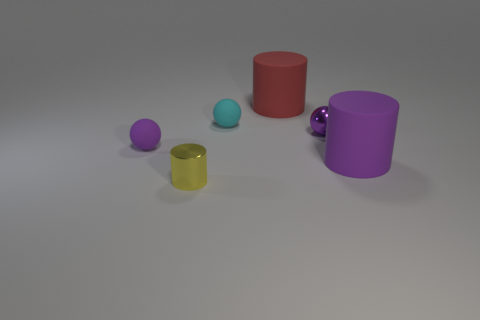What is the size of the rubber cylinder that is the same color as the metallic sphere?
Offer a very short reply. Large. There is another sphere that is the same color as the tiny metal sphere; what material is it?
Your answer should be very brief. Rubber. The tiny cylinder is what color?
Keep it short and to the point. Yellow. How many other objects are the same color as the metal ball?
Offer a terse response. 2. What number of other objects are there of the same material as the tiny cyan ball?
Provide a succinct answer. 3. There is a big matte thing behind the tiny cyan rubber object; does it have the same shape as the big purple matte thing?
Give a very brief answer. Yes. How many things are purple matte things left of the large purple rubber thing or yellow things?
Your answer should be very brief. 2. There is a purple matte object that is the same size as the red cylinder; what shape is it?
Provide a succinct answer. Cylinder. Does the rubber thing that is to the right of the shiny sphere have the same size as the metal thing that is behind the small yellow cylinder?
Provide a succinct answer. No. The thing that is made of the same material as the yellow cylinder is what color?
Give a very brief answer. Purple. 